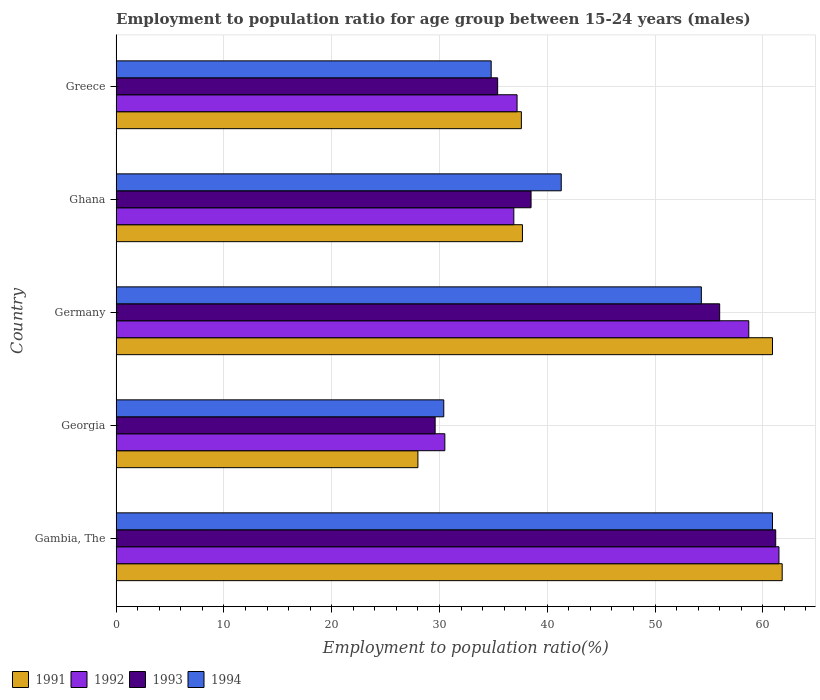How many different coloured bars are there?
Ensure brevity in your answer.  4. Are the number of bars per tick equal to the number of legend labels?
Your answer should be compact. Yes. How many bars are there on the 4th tick from the top?
Keep it short and to the point. 4. What is the employment to population ratio in 1992 in Gambia, The?
Keep it short and to the point. 61.5. Across all countries, what is the maximum employment to population ratio in 1994?
Give a very brief answer. 60.9. Across all countries, what is the minimum employment to population ratio in 1993?
Keep it short and to the point. 29.6. In which country was the employment to population ratio in 1991 maximum?
Give a very brief answer. Gambia, The. In which country was the employment to population ratio in 1991 minimum?
Offer a terse response. Georgia. What is the total employment to population ratio in 1993 in the graph?
Offer a terse response. 220.7. What is the difference between the employment to population ratio in 1991 in Georgia and that in Greece?
Make the answer very short. -9.6. What is the difference between the employment to population ratio in 1993 in Ghana and the employment to population ratio in 1992 in Germany?
Offer a very short reply. -20.2. What is the average employment to population ratio in 1991 per country?
Provide a succinct answer. 45.2. What is the difference between the employment to population ratio in 1993 and employment to population ratio in 1991 in Greece?
Your answer should be compact. -2.2. What is the ratio of the employment to population ratio in 1992 in Gambia, The to that in Georgia?
Offer a very short reply. 2.02. What is the difference between the highest and the second highest employment to population ratio in 1993?
Your answer should be very brief. 5.2. What is the difference between the highest and the lowest employment to population ratio in 1993?
Your response must be concise. 31.6. In how many countries, is the employment to population ratio in 1992 greater than the average employment to population ratio in 1992 taken over all countries?
Offer a very short reply. 2. Is it the case that in every country, the sum of the employment to population ratio in 1994 and employment to population ratio in 1992 is greater than the sum of employment to population ratio in 1993 and employment to population ratio in 1991?
Your answer should be compact. No. What does the 2nd bar from the top in Georgia represents?
Offer a terse response. 1993. What does the 3rd bar from the bottom in Georgia represents?
Your answer should be compact. 1993. Is it the case that in every country, the sum of the employment to population ratio in 1991 and employment to population ratio in 1993 is greater than the employment to population ratio in 1992?
Offer a terse response. Yes. Are all the bars in the graph horizontal?
Your answer should be compact. Yes. What is the difference between two consecutive major ticks on the X-axis?
Your answer should be very brief. 10. Does the graph contain any zero values?
Ensure brevity in your answer.  No. Does the graph contain grids?
Give a very brief answer. Yes. What is the title of the graph?
Offer a terse response. Employment to population ratio for age group between 15-24 years (males). What is the label or title of the X-axis?
Your answer should be compact. Employment to population ratio(%). What is the Employment to population ratio(%) in 1991 in Gambia, The?
Make the answer very short. 61.8. What is the Employment to population ratio(%) in 1992 in Gambia, The?
Offer a terse response. 61.5. What is the Employment to population ratio(%) of 1993 in Gambia, The?
Ensure brevity in your answer.  61.2. What is the Employment to population ratio(%) in 1994 in Gambia, The?
Your response must be concise. 60.9. What is the Employment to population ratio(%) in 1991 in Georgia?
Keep it short and to the point. 28. What is the Employment to population ratio(%) of 1992 in Georgia?
Ensure brevity in your answer.  30.5. What is the Employment to population ratio(%) in 1993 in Georgia?
Provide a succinct answer. 29.6. What is the Employment to population ratio(%) of 1994 in Georgia?
Ensure brevity in your answer.  30.4. What is the Employment to population ratio(%) in 1991 in Germany?
Your answer should be very brief. 60.9. What is the Employment to population ratio(%) in 1992 in Germany?
Ensure brevity in your answer.  58.7. What is the Employment to population ratio(%) in 1994 in Germany?
Your answer should be compact. 54.3. What is the Employment to population ratio(%) of 1991 in Ghana?
Your response must be concise. 37.7. What is the Employment to population ratio(%) in 1992 in Ghana?
Your answer should be very brief. 36.9. What is the Employment to population ratio(%) in 1993 in Ghana?
Your response must be concise. 38.5. What is the Employment to population ratio(%) in 1994 in Ghana?
Offer a very short reply. 41.3. What is the Employment to population ratio(%) of 1991 in Greece?
Give a very brief answer. 37.6. What is the Employment to population ratio(%) of 1992 in Greece?
Provide a succinct answer. 37.2. What is the Employment to population ratio(%) in 1993 in Greece?
Your response must be concise. 35.4. What is the Employment to population ratio(%) of 1994 in Greece?
Your answer should be compact. 34.8. Across all countries, what is the maximum Employment to population ratio(%) of 1991?
Give a very brief answer. 61.8. Across all countries, what is the maximum Employment to population ratio(%) in 1992?
Your answer should be very brief. 61.5. Across all countries, what is the maximum Employment to population ratio(%) in 1993?
Your response must be concise. 61.2. Across all countries, what is the maximum Employment to population ratio(%) of 1994?
Ensure brevity in your answer.  60.9. Across all countries, what is the minimum Employment to population ratio(%) of 1992?
Make the answer very short. 30.5. Across all countries, what is the minimum Employment to population ratio(%) of 1993?
Your response must be concise. 29.6. Across all countries, what is the minimum Employment to population ratio(%) of 1994?
Your response must be concise. 30.4. What is the total Employment to population ratio(%) in 1991 in the graph?
Provide a short and direct response. 226. What is the total Employment to population ratio(%) in 1992 in the graph?
Offer a very short reply. 224.8. What is the total Employment to population ratio(%) of 1993 in the graph?
Offer a terse response. 220.7. What is the total Employment to population ratio(%) of 1994 in the graph?
Ensure brevity in your answer.  221.7. What is the difference between the Employment to population ratio(%) of 1991 in Gambia, The and that in Georgia?
Offer a very short reply. 33.8. What is the difference between the Employment to population ratio(%) of 1993 in Gambia, The and that in Georgia?
Your response must be concise. 31.6. What is the difference between the Employment to population ratio(%) in 1994 in Gambia, The and that in Georgia?
Provide a short and direct response. 30.5. What is the difference between the Employment to population ratio(%) in 1991 in Gambia, The and that in Germany?
Give a very brief answer. 0.9. What is the difference between the Employment to population ratio(%) in 1993 in Gambia, The and that in Germany?
Offer a very short reply. 5.2. What is the difference between the Employment to population ratio(%) in 1991 in Gambia, The and that in Ghana?
Offer a terse response. 24.1. What is the difference between the Employment to population ratio(%) in 1992 in Gambia, The and that in Ghana?
Keep it short and to the point. 24.6. What is the difference between the Employment to population ratio(%) in 1993 in Gambia, The and that in Ghana?
Keep it short and to the point. 22.7. What is the difference between the Employment to population ratio(%) of 1994 in Gambia, The and that in Ghana?
Offer a very short reply. 19.6. What is the difference between the Employment to population ratio(%) of 1991 in Gambia, The and that in Greece?
Offer a very short reply. 24.2. What is the difference between the Employment to population ratio(%) in 1992 in Gambia, The and that in Greece?
Give a very brief answer. 24.3. What is the difference between the Employment to population ratio(%) of 1993 in Gambia, The and that in Greece?
Your answer should be compact. 25.8. What is the difference between the Employment to population ratio(%) in 1994 in Gambia, The and that in Greece?
Offer a terse response. 26.1. What is the difference between the Employment to population ratio(%) of 1991 in Georgia and that in Germany?
Provide a succinct answer. -32.9. What is the difference between the Employment to population ratio(%) of 1992 in Georgia and that in Germany?
Offer a terse response. -28.2. What is the difference between the Employment to population ratio(%) in 1993 in Georgia and that in Germany?
Your response must be concise. -26.4. What is the difference between the Employment to population ratio(%) of 1994 in Georgia and that in Germany?
Make the answer very short. -23.9. What is the difference between the Employment to population ratio(%) in 1991 in Georgia and that in Ghana?
Make the answer very short. -9.7. What is the difference between the Employment to population ratio(%) in 1992 in Georgia and that in Ghana?
Keep it short and to the point. -6.4. What is the difference between the Employment to population ratio(%) of 1993 in Georgia and that in Ghana?
Keep it short and to the point. -8.9. What is the difference between the Employment to population ratio(%) in 1991 in Georgia and that in Greece?
Provide a short and direct response. -9.6. What is the difference between the Employment to population ratio(%) in 1993 in Georgia and that in Greece?
Provide a short and direct response. -5.8. What is the difference between the Employment to population ratio(%) in 1994 in Georgia and that in Greece?
Offer a very short reply. -4.4. What is the difference between the Employment to population ratio(%) in 1991 in Germany and that in Ghana?
Make the answer very short. 23.2. What is the difference between the Employment to population ratio(%) of 1992 in Germany and that in Ghana?
Provide a succinct answer. 21.8. What is the difference between the Employment to population ratio(%) of 1991 in Germany and that in Greece?
Provide a short and direct response. 23.3. What is the difference between the Employment to population ratio(%) of 1993 in Germany and that in Greece?
Your answer should be compact. 20.6. What is the difference between the Employment to population ratio(%) of 1994 in Ghana and that in Greece?
Ensure brevity in your answer.  6.5. What is the difference between the Employment to population ratio(%) of 1991 in Gambia, The and the Employment to population ratio(%) of 1992 in Georgia?
Offer a terse response. 31.3. What is the difference between the Employment to population ratio(%) in 1991 in Gambia, The and the Employment to population ratio(%) in 1993 in Georgia?
Offer a terse response. 32.2. What is the difference between the Employment to population ratio(%) in 1991 in Gambia, The and the Employment to population ratio(%) in 1994 in Georgia?
Offer a terse response. 31.4. What is the difference between the Employment to population ratio(%) in 1992 in Gambia, The and the Employment to population ratio(%) in 1993 in Georgia?
Provide a short and direct response. 31.9. What is the difference between the Employment to population ratio(%) in 1992 in Gambia, The and the Employment to population ratio(%) in 1994 in Georgia?
Offer a terse response. 31.1. What is the difference between the Employment to population ratio(%) in 1993 in Gambia, The and the Employment to population ratio(%) in 1994 in Georgia?
Provide a short and direct response. 30.8. What is the difference between the Employment to population ratio(%) of 1991 in Gambia, The and the Employment to population ratio(%) of 1992 in Germany?
Make the answer very short. 3.1. What is the difference between the Employment to population ratio(%) in 1991 in Gambia, The and the Employment to population ratio(%) in 1993 in Germany?
Your answer should be very brief. 5.8. What is the difference between the Employment to population ratio(%) in 1991 in Gambia, The and the Employment to population ratio(%) in 1994 in Germany?
Your response must be concise. 7.5. What is the difference between the Employment to population ratio(%) in 1992 in Gambia, The and the Employment to population ratio(%) in 1994 in Germany?
Your response must be concise. 7.2. What is the difference between the Employment to population ratio(%) in 1993 in Gambia, The and the Employment to population ratio(%) in 1994 in Germany?
Keep it short and to the point. 6.9. What is the difference between the Employment to population ratio(%) of 1991 in Gambia, The and the Employment to population ratio(%) of 1992 in Ghana?
Your response must be concise. 24.9. What is the difference between the Employment to population ratio(%) of 1991 in Gambia, The and the Employment to population ratio(%) of 1993 in Ghana?
Ensure brevity in your answer.  23.3. What is the difference between the Employment to population ratio(%) in 1992 in Gambia, The and the Employment to population ratio(%) in 1993 in Ghana?
Make the answer very short. 23. What is the difference between the Employment to population ratio(%) in 1992 in Gambia, The and the Employment to population ratio(%) in 1994 in Ghana?
Ensure brevity in your answer.  20.2. What is the difference between the Employment to population ratio(%) of 1991 in Gambia, The and the Employment to population ratio(%) of 1992 in Greece?
Provide a short and direct response. 24.6. What is the difference between the Employment to population ratio(%) in 1991 in Gambia, The and the Employment to population ratio(%) in 1993 in Greece?
Offer a very short reply. 26.4. What is the difference between the Employment to population ratio(%) of 1992 in Gambia, The and the Employment to population ratio(%) of 1993 in Greece?
Give a very brief answer. 26.1. What is the difference between the Employment to population ratio(%) in 1992 in Gambia, The and the Employment to population ratio(%) in 1994 in Greece?
Offer a very short reply. 26.7. What is the difference between the Employment to population ratio(%) in 1993 in Gambia, The and the Employment to population ratio(%) in 1994 in Greece?
Keep it short and to the point. 26.4. What is the difference between the Employment to population ratio(%) of 1991 in Georgia and the Employment to population ratio(%) of 1992 in Germany?
Provide a succinct answer. -30.7. What is the difference between the Employment to population ratio(%) in 1991 in Georgia and the Employment to population ratio(%) in 1993 in Germany?
Make the answer very short. -28. What is the difference between the Employment to population ratio(%) in 1991 in Georgia and the Employment to population ratio(%) in 1994 in Germany?
Provide a short and direct response. -26.3. What is the difference between the Employment to population ratio(%) of 1992 in Georgia and the Employment to population ratio(%) of 1993 in Germany?
Offer a terse response. -25.5. What is the difference between the Employment to population ratio(%) of 1992 in Georgia and the Employment to population ratio(%) of 1994 in Germany?
Provide a short and direct response. -23.8. What is the difference between the Employment to population ratio(%) in 1993 in Georgia and the Employment to population ratio(%) in 1994 in Germany?
Give a very brief answer. -24.7. What is the difference between the Employment to population ratio(%) of 1991 in Georgia and the Employment to population ratio(%) of 1993 in Ghana?
Your answer should be very brief. -10.5. What is the difference between the Employment to population ratio(%) in 1992 in Georgia and the Employment to population ratio(%) in 1993 in Ghana?
Offer a very short reply. -8. What is the difference between the Employment to population ratio(%) of 1993 in Georgia and the Employment to population ratio(%) of 1994 in Ghana?
Your answer should be compact. -11.7. What is the difference between the Employment to population ratio(%) of 1991 in Georgia and the Employment to population ratio(%) of 1992 in Greece?
Offer a terse response. -9.2. What is the difference between the Employment to population ratio(%) in 1992 in Georgia and the Employment to population ratio(%) in 1994 in Greece?
Your answer should be very brief. -4.3. What is the difference between the Employment to population ratio(%) in 1993 in Georgia and the Employment to population ratio(%) in 1994 in Greece?
Ensure brevity in your answer.  -5.2. What is the difference between the Employment to population ratio(%) in 1991 in Germany and the Employment to population ratio(%) in 1993 in Ghana?
Provide a short and direct response. 22.4. What is the difference between the Employment to population ratio(%) in 1991 in Germany and the Employment to population ratio(%) in 1994 in Ghana?
Make the answer very short. 19.6. What is the difference between the Employment to population ratio(%) of 1992 in Germany and the Employment to population ratio(%) of 1993 in Ghana?
Make the answer very short. 20.2. What is the difference between the Employment to population ratio(%) in 1991 in Germany and the Employment to population ratio(%) in 1992 in Greece?
Your answer should be very brief. 23.7. What is the difference between the Employment to population ratio(%) in 1991 in Germany and the Employment to population ratio(%) in 1993 in Greece?
Give a very brief answer. 25.5. What is the difference between the Employment to population ratio(%) in 1991 in Germany and the Employment to population ratio(%) in 1994 in Greece?
Give a very brief answer. 26.1. What is the difference between the Employment to population ratio(%) in 1992 in Germany and the Employment to population ratio(%) in 1993 in Greece?
Ensure brevity in your answer.  23.3. What is the difference between the Employment to population ratio(%) in 1992 in Germany and the Employment to population ratio(%) in 1994 in Greece?
Give a very brief answer. 23.9. What is the difference between the Employment to population ratio(%) in 1993 in Germany and the Employment to population ratio(%) in 1994 in Greece?
Your response must be concise. 21.2. What is the difference between the Employment to population ratio(%) of 1991 in Ghana and the Employment to population ratio(%) of 1992 in Greece?
Offer a very short reply. 0.5. What is the difference between the Employment to population ratio(%) of 1991 in Ghana and the Employment to population ratio(%) of 1993 in Greece?
Keep it short and to the point. 2.3. What is the difference between the Employment to population ratio(%) of 1991 in Ghana and the Employment to population ratio(%) of 1994 in Greece?
Offer a very short reply. 2.9. What is the difference between the Employment to population ratio(%) of 1993 in Ghana and the Employment to population ratio(%) of 1994 in Greece?
Offer a terse response. 3.7. What is the average Employment to population ratio(%) in 1991 per country?
Give a very brief answer. 45.2. What is the average Employment to population ratio(%) of 1992 per country?
Provide a succinct answer. 44.96. What is the average Employment to population ratio(%) in 1993 per country?
Provide a short and direct response. 44.14. What is the average Employment to population ratio(%) in 1994 per country?
Provide a short and direct response. 44.34. What is the difference between the Employment to population ratio(%) of 1991 and Employment to population ratio(%) of 1992 in Gambia, The?
Make the answer very short. 0.3. What is the difference between the Employment to population ratio(%) in 1991 and Employment to population ratio(%) in 1993 in Gambia, The?
Your answer should be very brief. 0.6. What is the difference between the Employment to population ratio(%) of 1991 and Employment to population ratio(%) of 1994 in Gambia, The?
Provide a succinct answer. 0.9. What is the difference between the Employment to population ratio(%) of 1992 and Employment to population ratio(%) of 1994 in Gambia, The?
Offer a terse response. 0.6. What is the difference between the Employment to population ratio(%) of 1993 and Employment to population ratio(%) of 1994 in Gambia, The?
Give a very brief answer. 0.3. What is the difference between the Employment to population ratio(%) of 1991 and Employment to population ratio(%) of 1992 in Georgia?
Provide a short and direct response. -2.5. What is the difference between the Employment to population ratio(%) in 1991 and Employment to population ratio(%) in 1994 in Georgia?
Keep it short and to the point. -2.4. What is the difference between the Employment to population ratio(%) of 1993 and Employment to population ratio(%) of 1994 in Georgia?
Offer a very short reply. -0.8. What is the difference between the Employment to population ratio(%) in 1991 and Employment to population ratio(%) in 1992 in Ghana?
Make the answer very short. 0.8. What is the difference between the Employment to population ratio(%) of 1991 and Employment to population ratio(%) of 1994 in Ghana?
Provide a short and direct response. -3.6. What is the difference between the Employment to population ratio(%) in 1992 and Employment to population ratio(%) in 1993 in Ghana?
Give a very brief answer. -1.6. What is the difference between the Employment to population ratio(%) in 1993 and Employment to population ratio(%) in 1994 in Ghana?
Provide a succinct answer. -2.8. What is the difference between the Employment to population ratio(%) of 1991 and Employment to population ratio(%) of 1992 in Greece?
Your response must be concise. 0.4. What is the difference between the Employment to population ratio(%) of 1991 and Employment to population ratio(%) of 1993 in Greece?
Make the answer very short. 2.2. What is the difference between the Employment to population ratio(%) of 1991 and Employment to population ratio(%) of 1994 in Greece?
Offer a terse response. 2.8. What is the difference between the Employment to population ratio(%) of 1992 and Employment to population ratio(%) of 1993 in Greece?
Keep it short and to the point. 1.8. What is the ratio of the Employment to population ratio(%) in 1991 in Gambia, The to that in Georgia?
Provide a succinct answer. 2.21. What is the ratio of the Employment to population ratio(%) of 1992 in Gambia, The to that in Georgia?
Provide a succinct answer. 2.02. What is the ratio of the Employment to population ratio(%) of 1993 in Gambia, The to that in Georgia?
Ensure brevity in your answer.  2.07. What is the ratio of the Employment to population ratio(%) in 1994 in Gambia, The to that in Georgia?
Make the answer very short. 2. What is the ratio of the Employment to population ratio(%) of 1991 in Gambia, The to that in Germany?
Your answer should be very brief. 1.01. What is the ratio of the Employment to population ratio(%) of 1992 in Gambia, The to that in Germany?
Provide a short and direct response. 1.05. What is the ratio of the Employment to population ratio(%) of 1993 in Gambia, The to that in Germany?
Ensure brevity in your answer.  1.09. What is the ratio of the Employment to population ratio(%) of 1994 in Gambia, The to that in Germany?
Offer a very short reply. 1.12. What is the ratio of the Employment to population ratio(%) of 1991 in Gambia, The to that in Ghana?
Keep it short and to the point. 1.64. What is the ratio of the Employment to population ratio(%) in 1993 in Gambia, The to that in Ghana?
Provide a short and direct response. 1.59. What is the ratio of the Employment to population ratio(%) of 1994 in Gambia, The to that in Ghana?
Offer a very short reply. 1.47. What is the ratio of the Employment to population ratio(%) of 1991 in Gambia, The to that in Greece?
Your answer should be very brief. 1.64. What is the ratio of the Employment to population ratio(%) in 1992 in Gambia, The to that in Greece?
Provide a short and direct response. 1.65. What is the ratio of the Employment to population ratio(%) in 1993 in Gambia, The to that in Greece?
Make the answer very short. 1.73. What is the ratio of the Employment to population ratio(%) in 1994 in Gambia, The to that in Greece?
Ensure brevity in your answer.  1.75. What is the ratio of the Employment to population ratio(%) in 1991 in Georgia to that in Germany?
Provide a short and direct response. 0.46. What is the ratio of the Employment to population ratio(%) in 1992 in Georgia to that in Germany?
Provide a short and direct response. 0.52. What is the ratio of the Employment to population ratio(%) of 1993 in Georgia to that in Germany?
Provide a short and direct response. 0.53. What is the ratio of the Employment to population ratio(%) in 1994 in Georgia to that in Germany?
Offer a terse response. 0.56. What is the ratio of the Employment to population ratio(%) of 1991 in Georgia to that in Ghana?
Offer a very short reply. 0.74. What is the ratio of the Employment to population ratio(%) in 1992 in Georgia to that in Ghana?
Provide a short and direct response. 0.83. What is the ratio of the Employment to population ratio(%) of 1993 in Georgia to that in Ghana?
Your answer should be compact. 0.77. What is the ratio of the Employment to population ratio(%) of 1994 in Georgia to that in Ghana?
Offer a very short reply. 0.74. What is the ratio of the Employment to population ratio(%) of 1991 in Georgia to that in Greece?
Your answer should be very brief. 0.74. What is the ratio of the Employment to population ratio(%) in 1992 in Georgia to that in Greece?
Keep it short and to the point. 0.82. What is the ratio of the Employment to population ratio(%) of 1993 in Georgia to that in Greece?
Your answer should be compact. 0.84. What is the ratio of the Employment to population ratio(%) of 1994 in Georgia to that in Greece?
Ensure brevity in your answer.  0.87. What is the ratio of the Employment to population ratio(%) of 1991 in Germany to that in Ghana?
Provide a succinct answer. 1.62. What is the ratio of the Employment to population ratio(%) in 1992 in Germany to that in Ghana?
Your answer should be very brief. 1.59. What is the ratio of the Employment to population ratio(%) of 1993 in Germany to that in Ghana?
Offer a very short reply. 1.45. What is the ratio of the Employment to population ratio(%) of 1994 in Germany to that in Ghana?
Provide a short and direct response. 1.31. What is the ratio of the Employment to population ratio(%) of 1991 in Germany to that in Greece?
Your answer should be compact. 1.62. What is the ratio of the Employment to population ratio(%) in 1992 in Germany to that in Greece?
Make the answer very short. 1.58. What is the ratio of the Employment to population ratio(%) in 1993 in Germany to that in Greece?
Offer a terse response. 1.58. What is the ratio of the Employment to population ratio(%) of 1994 in Germany to that in Greece?
Your response must be concise. 1.56. What is the ratio of the Employment to population ratio(%) of 1993 in Ghana to that in Greece?
Your answer should be very brief. 1.09. What is the ratio of the Employment to population ratio(%) in 1994 in Ghana to that in Greece?
Your response must be concise. 1.19. What is the difference between the highest and the second highest Employment to population ratio(%) of 1991?
Give a very brief answer. 0.9. What is the difference between the highest and the second highest Employment to population ratio(%) in 1992?
Provide a succinct answer. 2.8. What is the difference between the highest and the second highest Employment to population ratio(%) in 1994?
Offer a very short reply. 6.6. What is the difference between the highest and the lowest Employment to population ratio(%) of 1991?
Provide a short and direct response. 33.8. What is the difference between the highest and the lowest Employment to population ratio(%) of 1992?
Offer a terse response. 31. What is the difference between the highest and the lowest Employment to population ratio(%) in 1993?
Give a very brief answer. 31.6. What is the difference between the highest and the lowest Employment to population ratio(%) in 1994?
Offer a terse response. 30.5. 